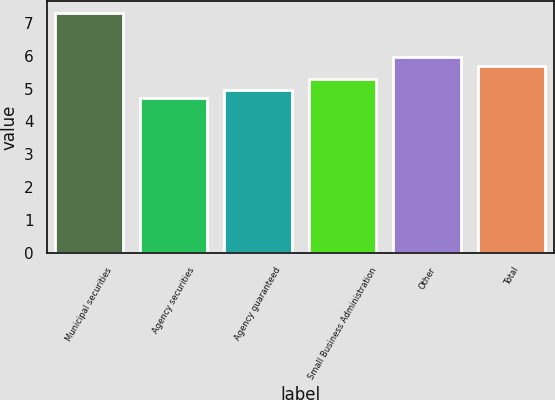Convert chart. <chart><loc_0><loc_0><loc_500><loc_500><bar_chart><fcel>Municipal securities<fcel>Agency securities<fcel>Agency guaranteed<fcel>Small Business Administration<fcel>Other<fcel>Total<nl><fcel>7.3<fcel>4.7<fcel>4.96<fcel>5.3<fcel>5.96<fcel>5.7<nl></chart> 